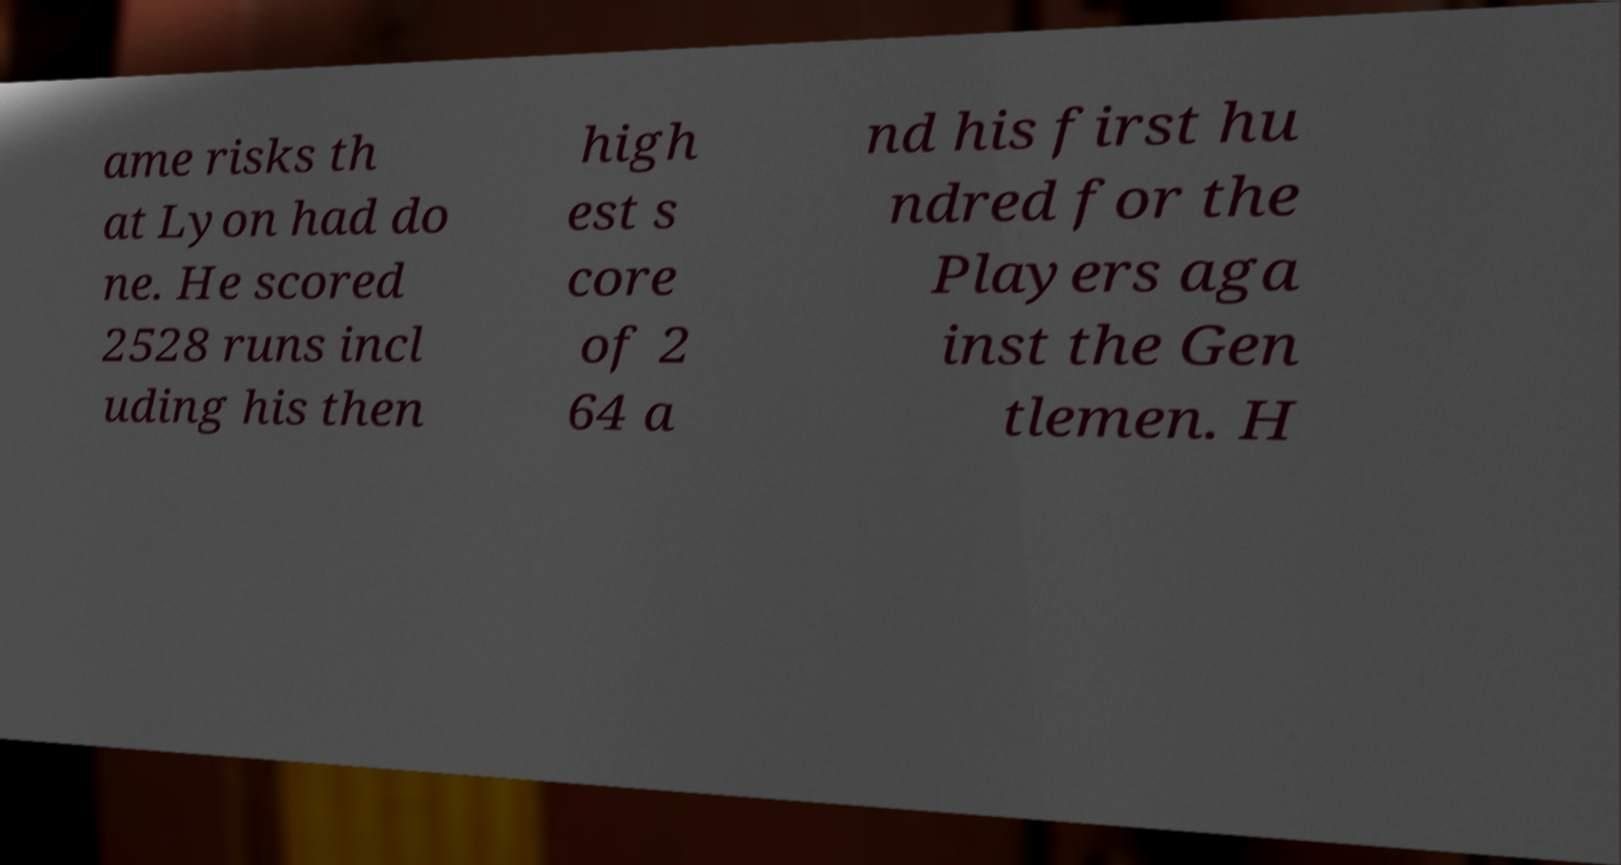Can you read and provide the text displayed in the image?This photo seems to have some interesting text. Can you extract and type it out for me? ame risks th at Lyon had do ne. He scored 2528 runs incl uding his then high est s core of 2 64 a nd his first hu ndred for the Players aga inst the Gen tlemen. H 